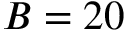<formula> <loc_0><loc_0><loc_500><loc_500>B = 2 0</formula> 